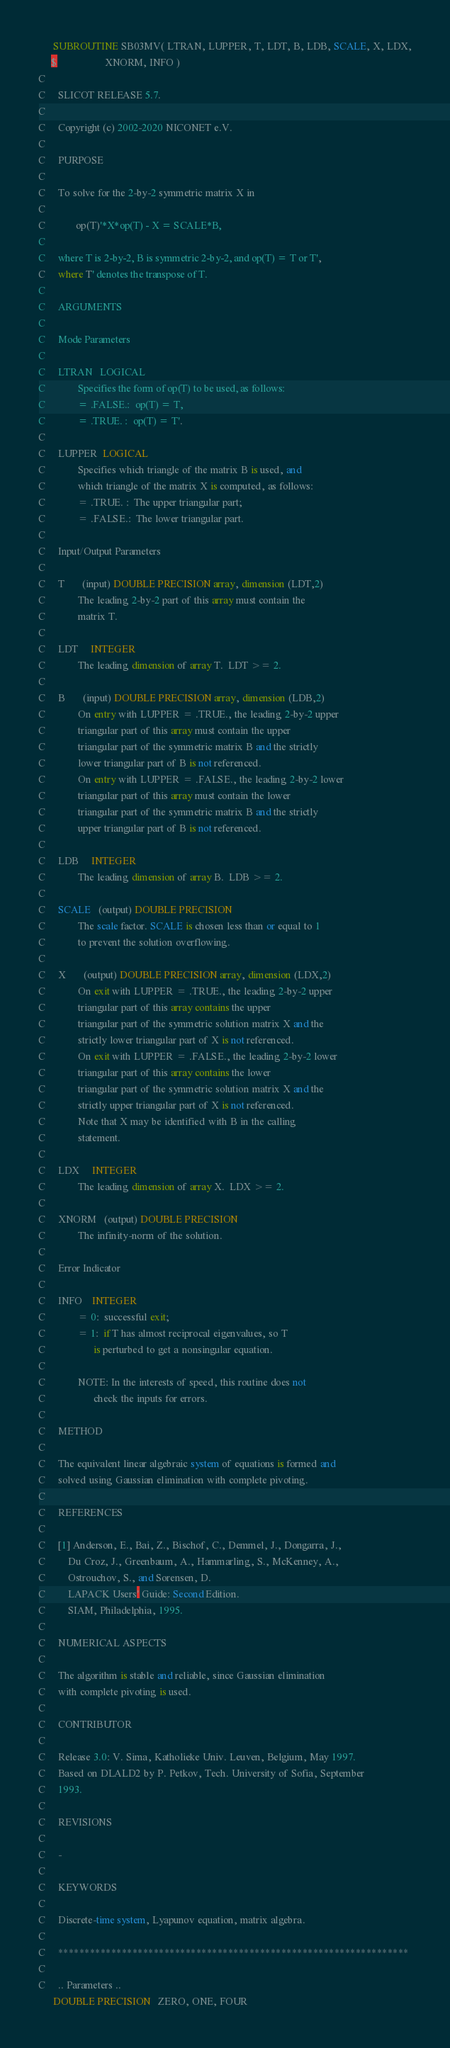<code> <loc_0><loc_0><loc_500><loc_500><_FORTRAN_>      SUBROUTINE SB03MV( LTRAN, LUPPER, T, LDT, B, LDB, SCALE, X, LDX,
     $                   XNORM, INFO )
C
C     SLICOT RELEASE 5.7.
C
C     Copyright (c) 2002-2020 NICONET e.V.
C
C     PURPOSE
C
C     To solve for the 2-by-2 symmetric matrix X in
C
C            op(T)'*X*op(T) - X = SCALE*B,
C
C     where T is 2-by-2, B is symmetric 2-by-2, and op(T) = T or T',
C     where T' denotes the transpose of T.
C
C     ARGUMENTS
C
C     Mode Parameters
C
C     LTRAN   LOGICAL
C             Specifies the form of op(T) to be used, as follows:
C             = .FALSE.:  op(T) = T,
C             = .TRUE. :  op(T) = T'.
C
C     LUPPER  LOGICAL
C             Specifies which triangle of the matrix B is used, and
C             which triangle of the matrix X is computed, as follows:
C             = .TRUE. :  The upper triangular part;
C             = .FALSE.:  The lower triangular part.
C
C     Input/Output Parameters
C
C     T       (input) DOUBLE PRECISION array, dimension (LDT,2)
C             The leading 2-by-2 part of this array must contain the
C             matrix T.
C
C     LDT     INTEGER
C             The leading dimension of array T.  LDT >= 2.
C
C     B       (input) DOUBLE PRECISION array, dimension (LDB,2)
C             On entry with LUPPER = .TRUE., the leading 2-by-2 upper
C             triangular part of this array must contain the upper
C             triangular part of the symmetric matrix B and the strictly
C             lower triangular part of B is not referenced.
C             On entry with LUPPER = .FALSE., the leading 2-by-2 lower
C             triangular part of this array must contain the lower
C             triangular part of the symmetric matrix B and the strictly
C             upper triangular part of B is not referenced.
C
C     LDB     INTEGER
C             The leading dimension of array B.  LDB >= 2.
C
C     SCALE   (output) DOUBLE PRECISION
C             The scale factor. SCALE is chosen less than or equal to 1
C             to prevent the solution overflowing.
C
C     X       (output) DOUBLE PRECISION array, dimension (LDX,2)
C             On exit with LUPPER = .TRUE., the leading 2-by-2 upper
C             triangular part of this array contains the upper
C             triangular part of the symmetric solution matrix X and the
C             strictly lower triangular part of X is not referenced.
C             On exit with LUPPER = .FALSE., the leading 2-by-2 lower
C             triangular part of this array contains the lower
C             triangular part of the symmetric solution matrix X and the
C             strictly upper triangular part of X is not referenced.
C             Note that X may be identified with B in the calling
C             statement.
C
C     LDX     INTEGER
C             The leading dimension of array X.  LDX >= 2.
C
C     XNORM   (output) DOUBLE PRECISION
C             The infinity-norm of the solution.
C
C     Error Indicator
C
C     INFO    INTEGER
C             = 0:  successful exit;
C             = 1:  if T has almost reciprocal eigenvalues, so T
C                   is perturbed to get a nonsingular equation.
C
C             NOTE: In the interests of speed, this routine does not
C                   check the inputs for errors.
C
C     METHOD
C
C     The equivalent linear algebraic system of equations is formed and
C     solved using Gaussian elimination with complete pivoting.
C
C     REFERENCES
C
C     [1] Anderson, E., Bai, Z., Bischof, C., Demmel, J., Dongarra, J.,
C         Du Croz, J., Greenbaum, A., Hammarling, S., McKenney, A.,
C         Ostrouchov, S., and Sorensen, D.
C         LAPACK Users' Guide: Second Edition.
C         SIAM, Philadelphia, 1995.
C
C     NUMERICAL ASPECTS
C
C     The algorithm is stable and reliable, since Gaussian elimination
C     with complete pivoting is used.
C
C     CONTRIBUTOR
C
C     Release 3.0: V. Sima, Katholieke Univ. Leuven, Belgium, May 1997.
C     Based on DLALD2 by P. Petkov, Tech. University of Sofia, September
C     1993.
C
C     REVISIONS
C
C     -
C
C     KEYWORDS
C
C     Discrete-time system, Lyapunov equation, matrix algebra.
C
C     ******************************************************************
C
C     .. Parameters ..
      DOUBLE PRECISION   ZERO, ONE, FOUR</code> 